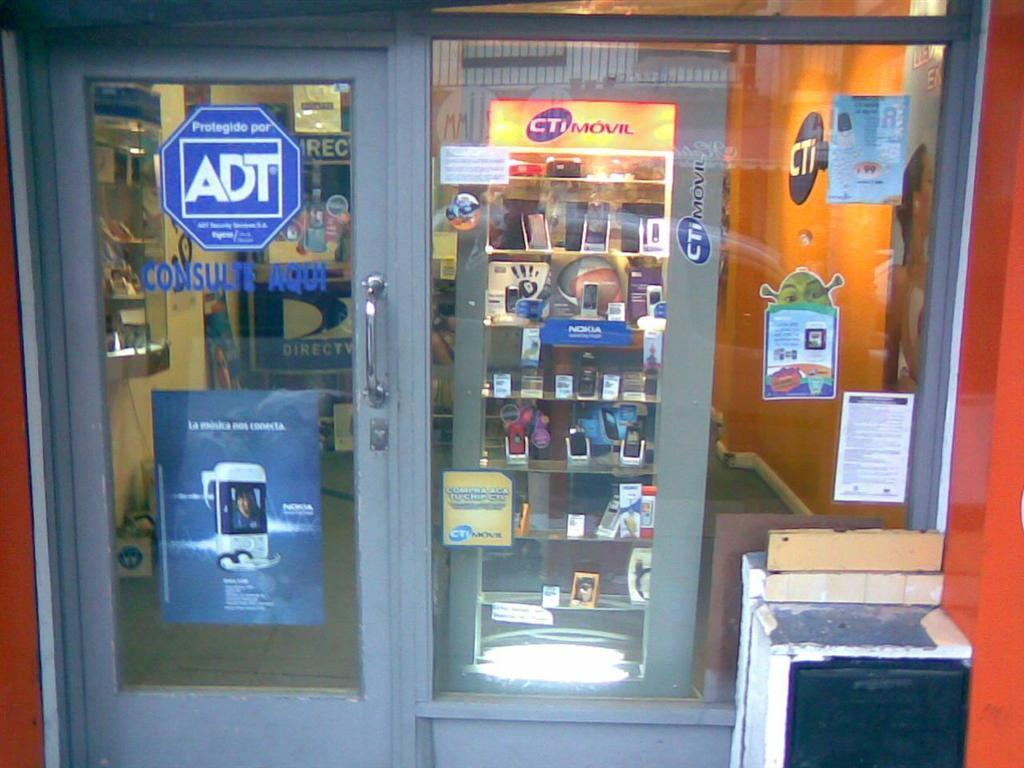What type of establishment is depicted in the image? The image is of a mobile stall. How are the mobiles organized in the stall? The mobiles are arranged in an order in the glass racks. What can be seen on the glass in the image? Labels are stuck to the glass. What architectural features are present in the image? There is a wall and a door with a door handle in the image. What type of play is happening in the image? There is no play or any indication of a play happening in the image, as it depicts a mobile stall with mobiles arranged in glass racks. 